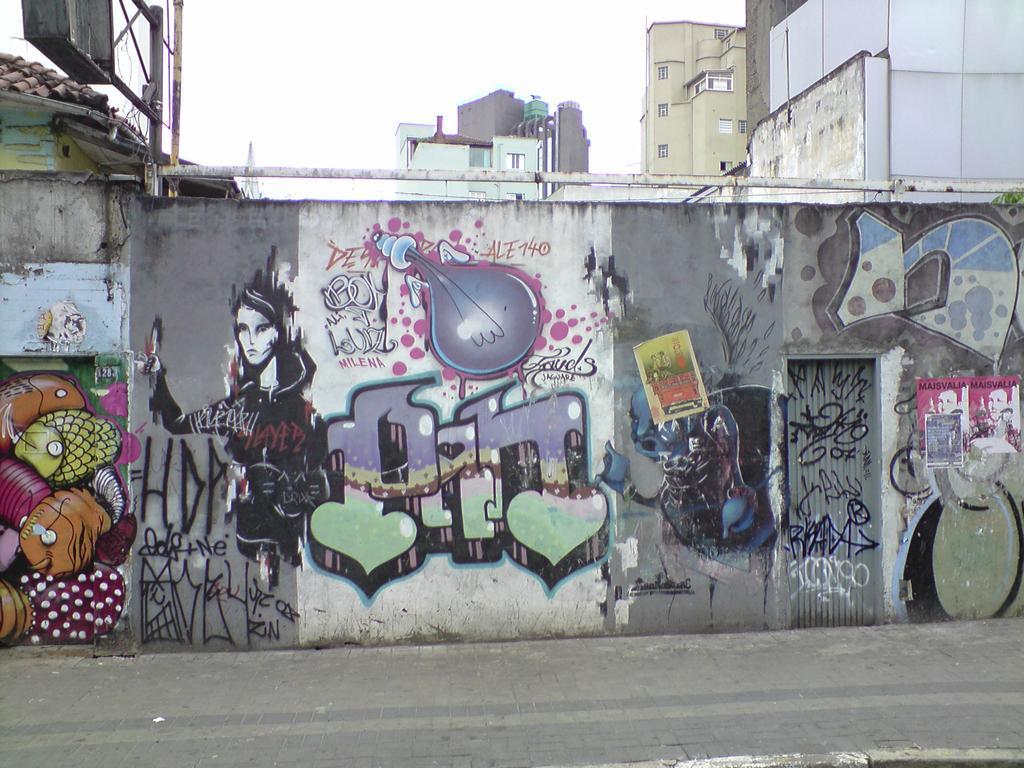Please provide a concise description of this image. In this picture there are buildings and there is a painting of a person and fishes and bulb and text on the wall and there are roof tiles on the top of the building and there is a board on the pole. At the top there is sky. At the bottom there is a road. 